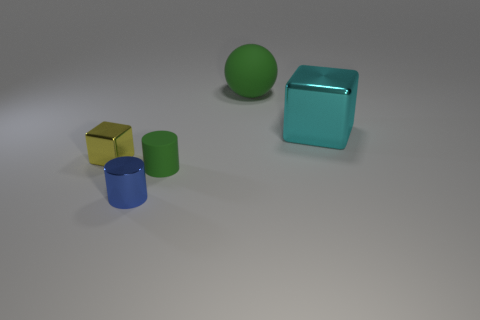There is a thing that is to the right of the large green thing; is its size the same as the rubber thing on the left side of the big green object?
Keep it short and to the point. No. How many objects are either small cylinders or big cyan things?
Offer a terse response. 3. What size is the green rubber thing behind the large cyan shiny block?
Offer a very short reply. Large. There is a green thing that is to the right of the green object that is on the left side of the large green object; how many cubes are on the right side of it?
Your answer should be compact. 1. Is the color of the matte ball the same as the small rubber thing?
Provide a succinct answer. Yes. How many large objects are both in front of the large sphere and to the left of the large metal object?
Provide a succinct answer. 0. The green matte object that is on the left side of the big green object has what shape?
Offer a terse response. Cylinder. Are there fewer large balls that are in front of the large sphere than metal blocks behind the yellow block?
Offer a very short reply. Yes. Are the green object in front of the yellow cube and the large cyan thing behind the small yellow cube made of the same material?
Your response must be concise. No. There is a blue thing; what shape is it?
Your answer should be very brief. Cylinder. 